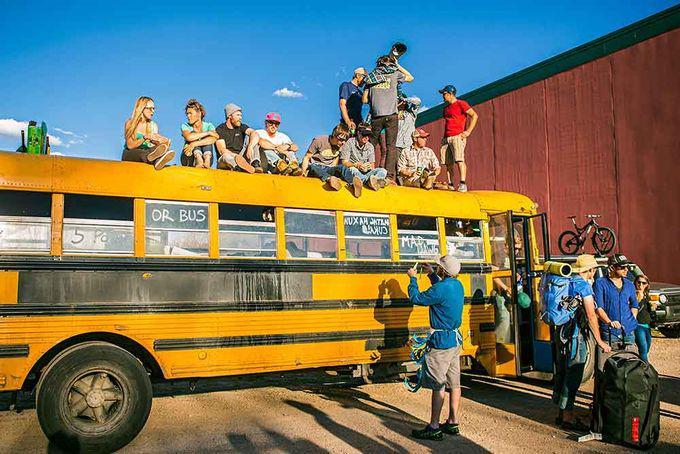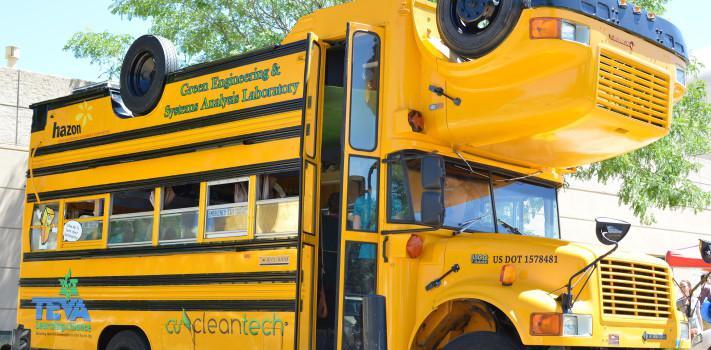The first image is the image on the left, the second image is the image on the right. Considering the images on both sides, is "An image includes a girl in jeans standing in front of a bus decorated with cartoon faces in the windows." valid? Answer yes or no. No. The first image is the image on the left, the second image is the image on the right. Assess this claim about the two images: "One bus is a Magic School Bus and one isn't.". Correct or not? Answer yes or no. No. 